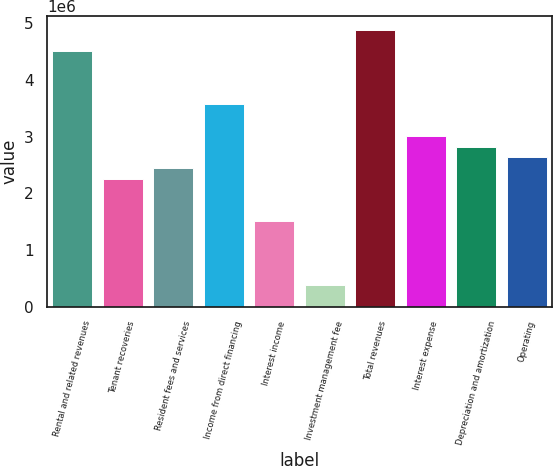Convert chart. <chart><loc_0><loc_0><loc_500><loc_500><bar_chart><fcel>Rental and related revenues<fcel>Tenant recoveries<fcel>Resident fees and services<fcel>Income from direct financing<fcel>Interest income<fcel>Investment management fee<fcel>Total revenues<fcel>Interest expense<fcel>Depreciation and amortization<fcel>Operating<nl><fcel>4.51193e+06<fcel>2.25596e+06<fcel>2.44396e+06<fcel>3.57194e+06<fcel>1.50398e+06<fcel>375994<fcel>4.88792e+06<fcel>3.00795e+06<fcel>2.81995e+06<fcel>2.63196e+06<nl></chart> 